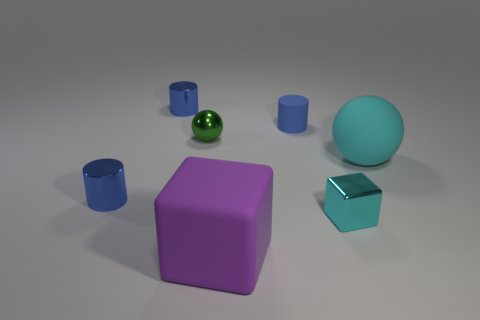Are there any purple cylinders that have the same size as the cyan rubber ball?
Offer a terse response. No. Is there a tiny sphere that has the same color as the small rubber cylinder?
Keep it short and to the point. No. Is there anything else that has the same size as the blue matte thing?
Ensure brevity in your answer.  Yes. How many matte cylinders are the same color as the small shiny sphere?
Ensure brevity in your answer.  0. There is a small block; does it have the same color as the ball that is in front of the small metallic ball?
Your answer should be very brief. Yes. How many things are tiny purple metallic balls or tiny objects behind the blue rubber cylinder?
Your response must be concise. 1. What size is the cyan thing that is in front of the ball that is in front of the green metallic thing?
Offer a very short reply. Small. Are there the same number of small blue shiny objects behind the tiny green ball and rubber blocks on the left side of the purple block?
Provide a short and direct response. No. There is a blue metallic object that is behind the green metallic ball; is there a green metallic sphere behind it?
Keep it short and to the point. No. What shape is the large purple thing that is made of the same material as the cyan sphere?
Ensure brevity in your answer.  Cube. 